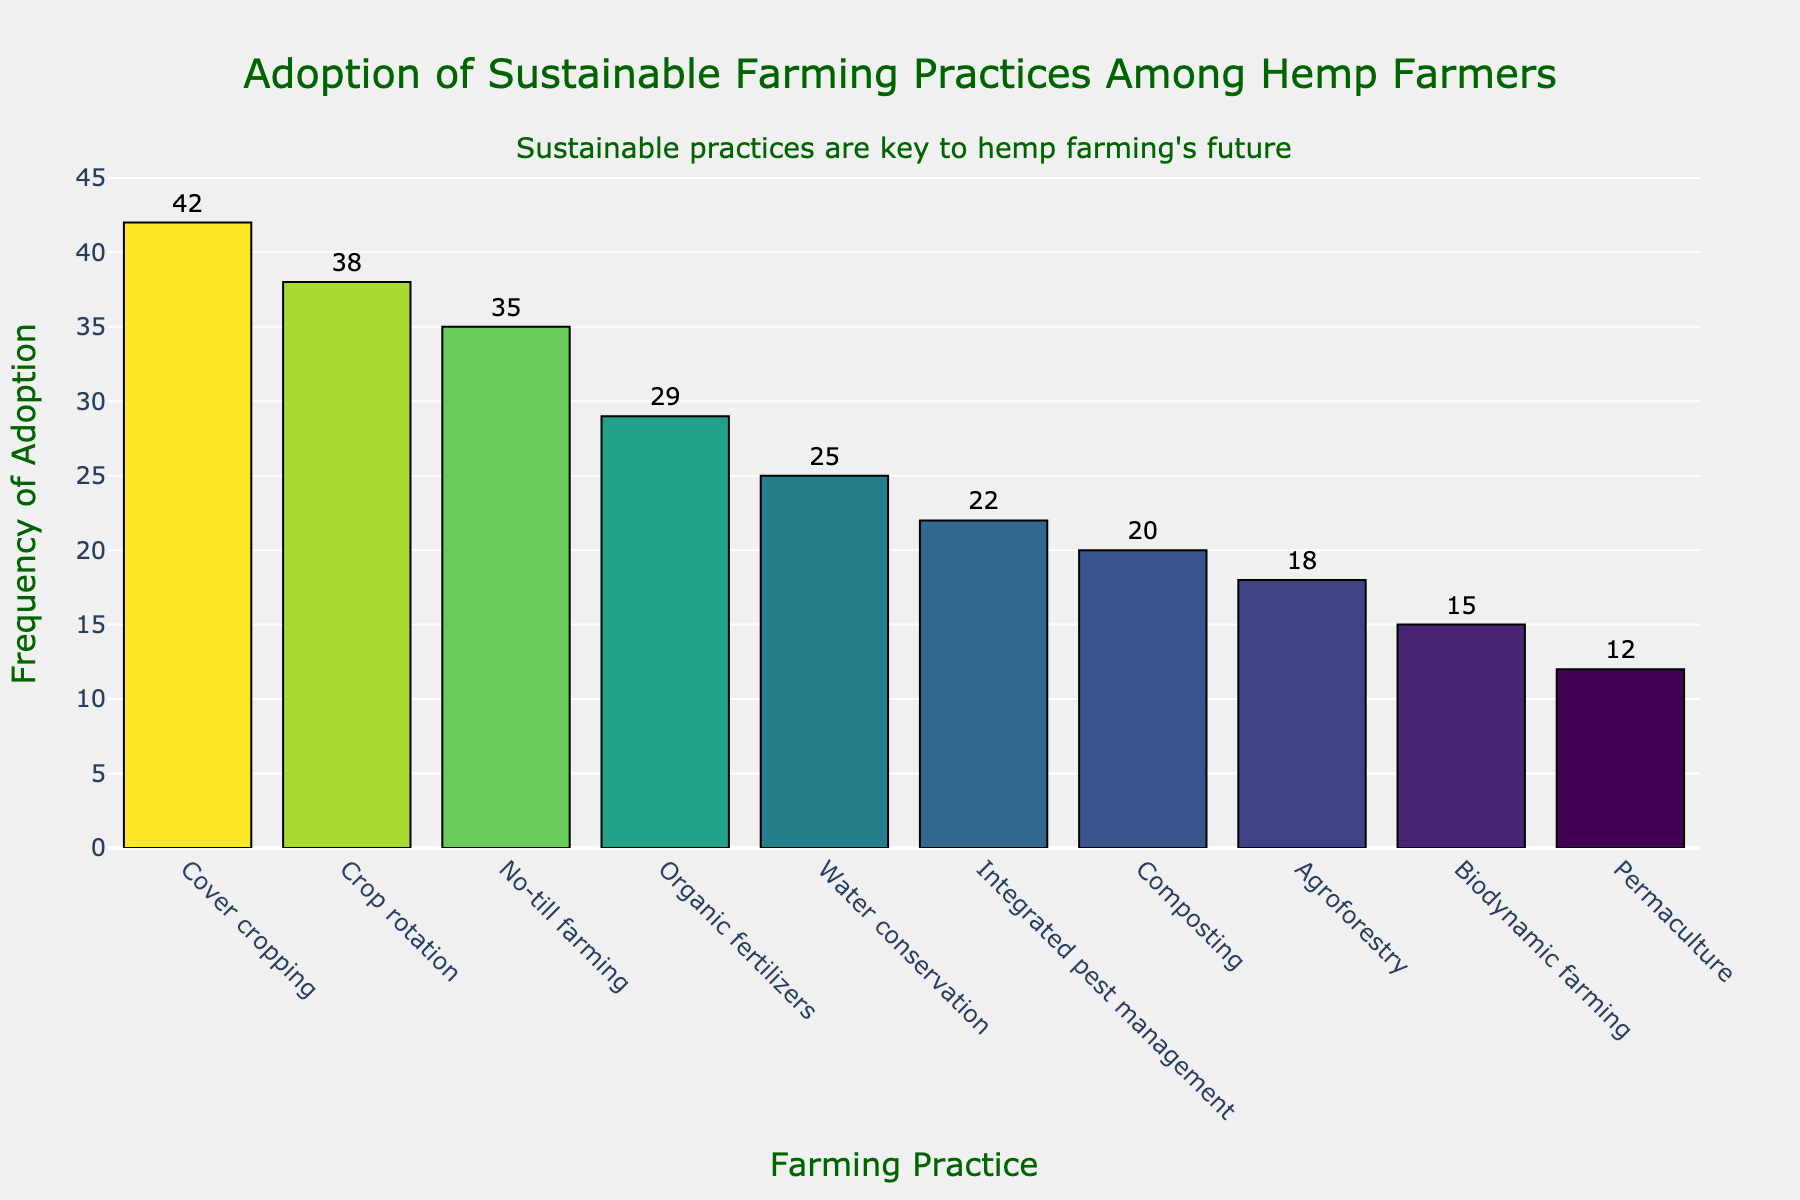How many sustainable farming practices are listed in the histogram? By examining the number of different farming practices on the x-axis, we can count a total of 10 practices listed.
Answer: 10 Which farming practice has the highest adoption frequency? Observe the heights of the bars and the corresponding labels on the x-axis and y-axis. The bar for "Cover cropping" is the tallest, indicating it has the highest frequency.
Answer: Cover cropping What is the frequency difference between the highest and lowest adopted practices? The highest frequency is for "Cover cropping" with 42, and the lowest is for "Permaculture" with 12. Subtracting these gives 42 - 12.
Answer: 30 What are the top three most adopted farming practices? Identify the three tallest bars on the histogram. They correspond to "Cover cropping" (42), "Crop rotation" (38), and "No-till farming" (35).
Answer: Cover cropping, Crop rotation, No-till farming How many practices have adoption frequencies above 30? Count the bars that have frequencies above the 30 mark on the y-axis: "Cover cropping", "Crop rotation", and "No-till farming".
Answer: 3 What's the average frequency of adoption for all sustainable practices? Sum the frequencies (42 + 38 + 35 + 29 + 25 + 22 + 20 + 18 + 15 + 12) = 256, and divide by the number of practices (10). 256 / 10.
Answer: 25.6 Which farming practice has the second-lowest adoption frequency? Looking at the second shortest bar on the histogram, it corresponds to "Biodynamic farming" with a frequency of 15.
Answer: Biodynamic farming Compare the adoption frequencies of "Organic fertilizers" and "Composting". Which is higher and by how much? From the histogram, "Organic fertilizers" has a frequency of 29, while "Composting" has 20. The difference is 29 - 20.
Answer: Organic fertilizers, by 9 What is the total frequency of adoption for all practices combined? Add up all the frequencies as shown on the bars: 42 + 38 + 35 + 29 + 25 + 22 + 20 + 18 + 15 + 12 = 256.
Answer: 256 How does the adoption frequency of "Agroforestry" compare to "Water conservation"? The histogram shows "Agroforestry" with a frequency of 18 and "Water conservation" with 25. Comparing, "Water conservation" is higher.
Answer: Water conservation is higher 